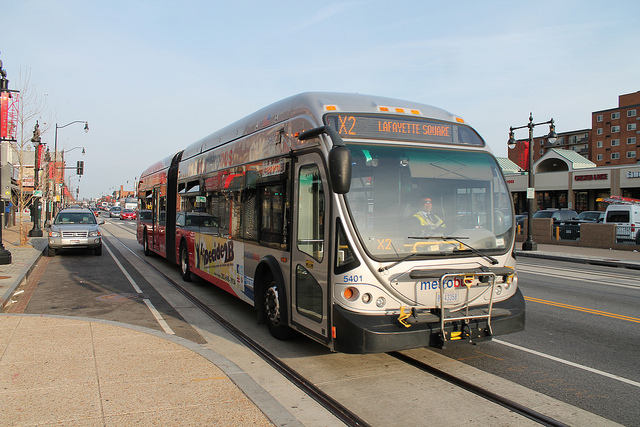What type of vehicle is dominating the image? The most prominent vehicle in the image is a city bus, identifiable by its size, design, and the text on its display indicating it is on the X2 route to Lafayette Square. What features can you describe about the bus? This bus is a modern articulated model, often referred to as a bendy or accordion bus due to its flexible center joint. It features a sleek design with advertising on the side and an accessible low floor for passengers. The bus's display above the windshield shows the route number and destination. 